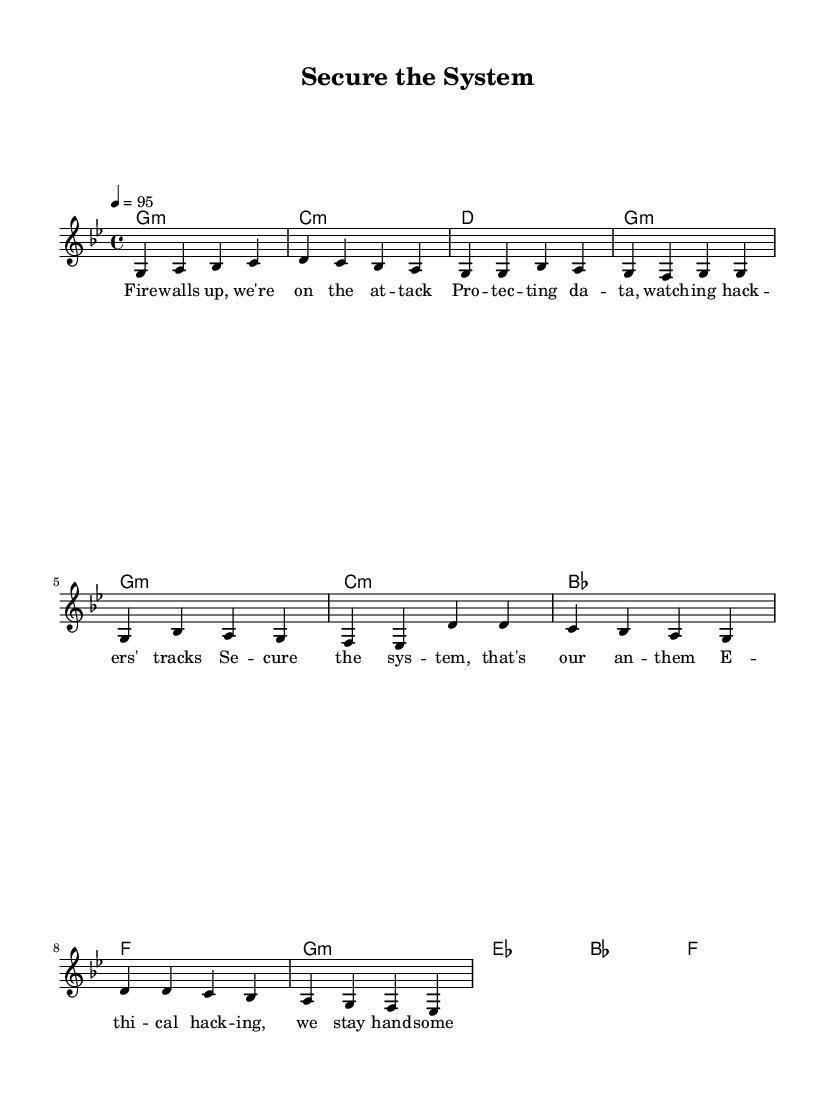What is the key signature of this music? The key signature is G minor, which has two flats: B flat and E flat. This can be seen in the initial instruction of the piece that sets the tonality.
Answer: G minor What is the time signature of this music? The time signature is 4/4, indicated at the beginning of the score. This means there are four beats in each measure, and the quarter note gets one beat.
Answer: 4/4 What is the tempo marking for this piece? The tempo marking indicates a speed of 95 beats per minute, which is specified in the tempo indication at the start of the score.
Answer: 95 What are the lyrics of the chorus? The chorus lyrics are "Secure the system, that's our anthem / Ethical hacking, we stay handsome." This is found in the lyric section dedicated to the chorus part of the song.
Answer: "Secure the system, that's our anthem / Ethical hacking, we stay handsome." How many measures are in the verse? There are eight measures in the verse as indicated by the distinct phrasing of the melody and the lyrics assigned to this section. Each grouping represents one measure in the musical structure.
Answer: 8 What type of harmony is primarily used in the Chorus? The harmony primarily used in the chorus is minor, specifically G minor in the first chord and moving to E flat and B flat. The use of minor chords contributes to the overall mood of the piece.
Answer: minor What theme do the lyrics celebrate? The lyrics celebrate the theme of information security and ethical hacking, focusing on protecting data and systems from cyber threats, as expressed in the verses and chorus.
Answer: ethical hacking 